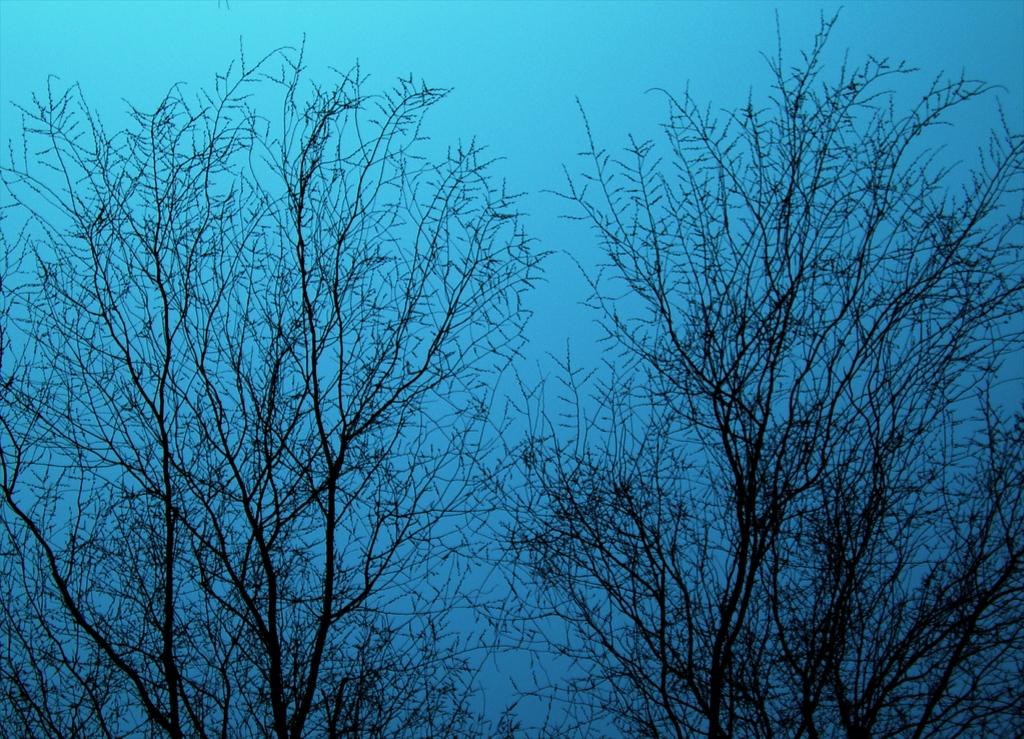What type of vegetation can be seen in the image? There are trees in the image. What color is the sky in the image? The sky is blue in the image. Where is the basket located in the image? There is no basket present in the image. How many feet can be seen in the image? There are no feet visible in the image. 